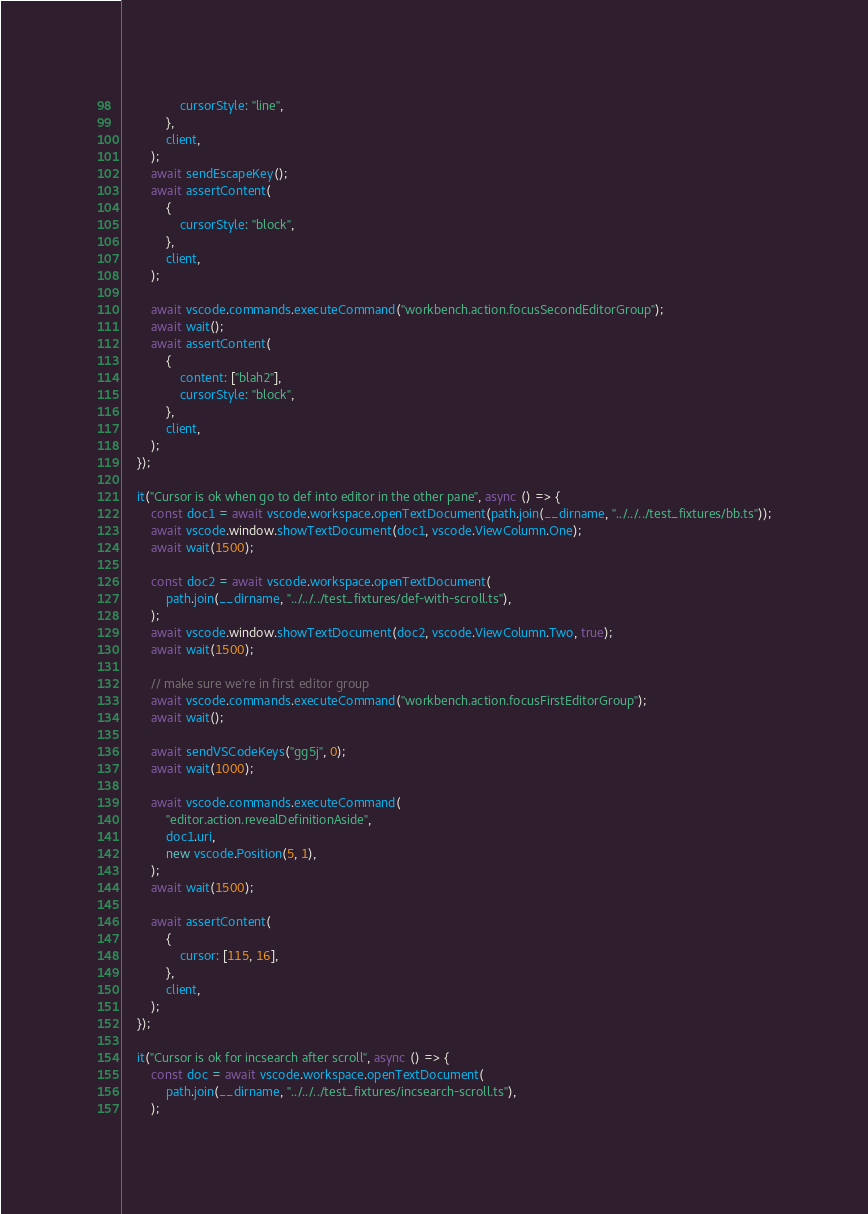Convert code to text. <code><loc_0><loc_0><loc_500><loc_500><_TypeScript_>                cursorStyle: "line",
            },
            client,
        );
        await sendEscapeKey();
        await assertContent(
            {
                cursorStyle: "block",
            },
            client,
        );

        await vscode.commands.executeCommand("workbench.action.focusSecondEditorGroup");
        await wait();
        await assertContent(
            {
                content: ["blah2"],
                cursorStyle: "block",
            },
            client,
        );
    });

    it("Cursor is ok when go to def into editor in the other pane", async () => {
        const doc1 = await vscode.workspace.openTextDocument(path.join(__dirname, "../../../test_fixtures/bb.ts"));
        await vscode.window.showTextDocument(doc1, vscode.ViewColumn.One);
        await wait(1500);

        const doc2 = await vscode.workspace.openTextDocument(
            path.join(__dirname, "../../../test_fixtures/def-with-scroll.ts"),
        );
        await vscode.window.showTextDocument(doc2, vscode.ViewColumn.Two, true);
        await wait(1500);

        // make sure we're in first editor group
        await vscode.commands.executeCommand("workbench.action.focusFirstEditorGroup");
        await wait();

        await sendVSCodeKeys("gg5j", 0);
        await wait(1000);

        await vscode.commands.executeCommand(
            "editor.action.revealDefinitionAside",
            doc1.uri,
            new vscode.Position(5, 1),
        );
        await wait(1500);

        await assertContent(
            {
                cursor: [115, 16],
            },
            client,
        );
    });

    it("Cursor is ok for incsearch after scroll", async () => {
        const doc = await vscode.workspace.openTextDocument(
            path.join(__dirname, "../../../test_fixtures/incsearch-scroll.ts"),
        );</code> 